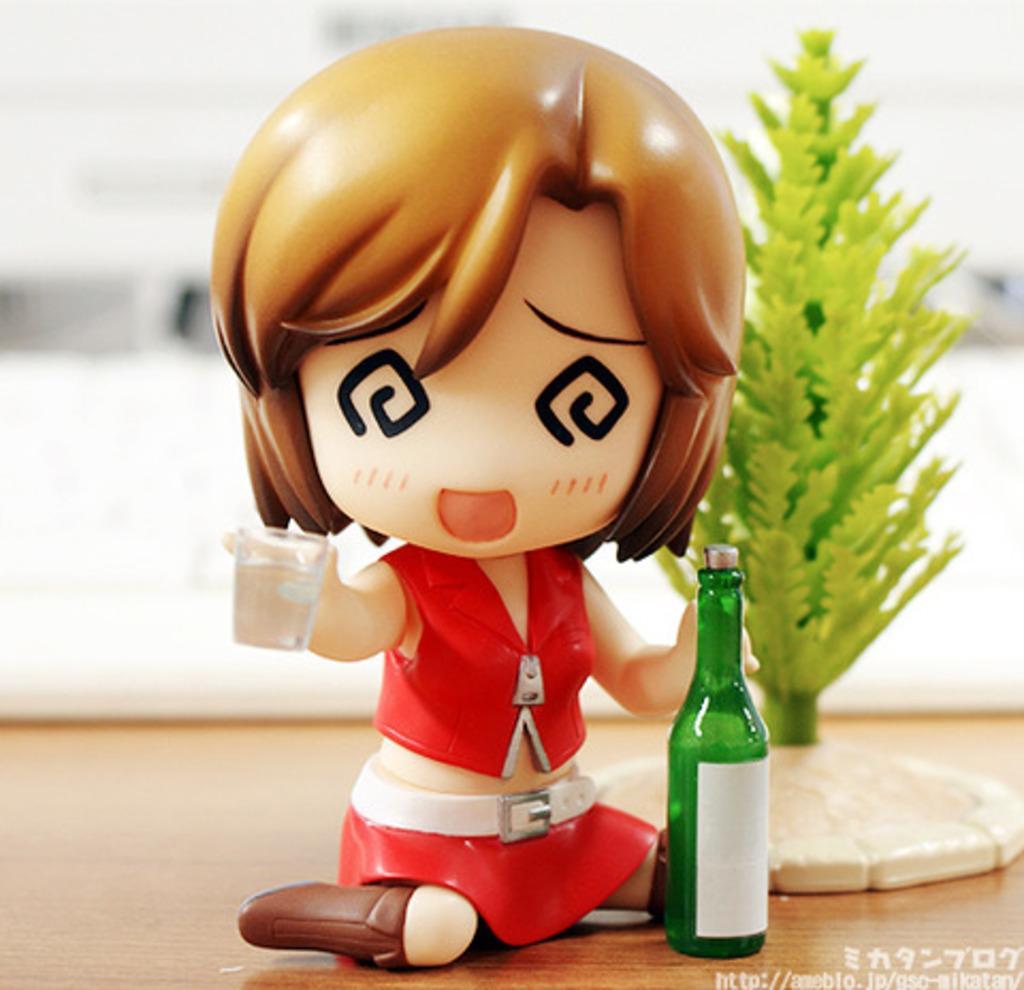In one or two sentences, can you explain what this image depicts? As we can see in the image there is a plant, toy and bottle on table. 